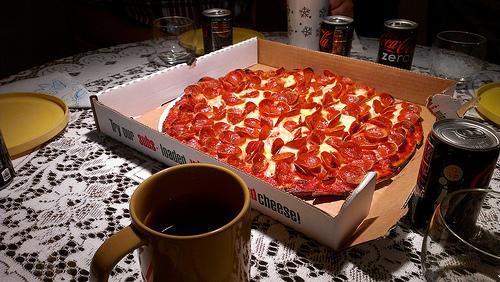How many coke cans are visible?
Give a very brief answer. 4. 